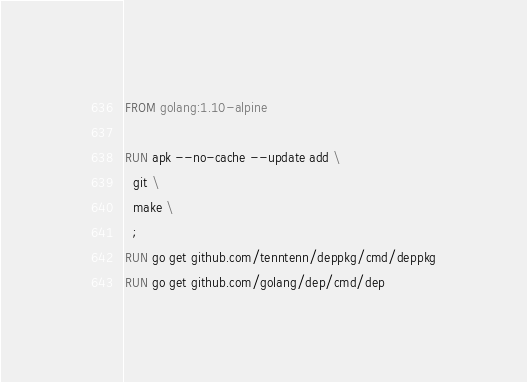<code> <loc_0><loc_0><loc_500><loc_500><_Dockerfile_>FROM golang:1.10-alpine

RUN apk --no-cache --update add \
  git \
  make \
  ;
RUN go get github.com/tenntenn/deppkg/cmd/deppkg
RUN go get github.com/golang/dep/cmd/dep
</code> 